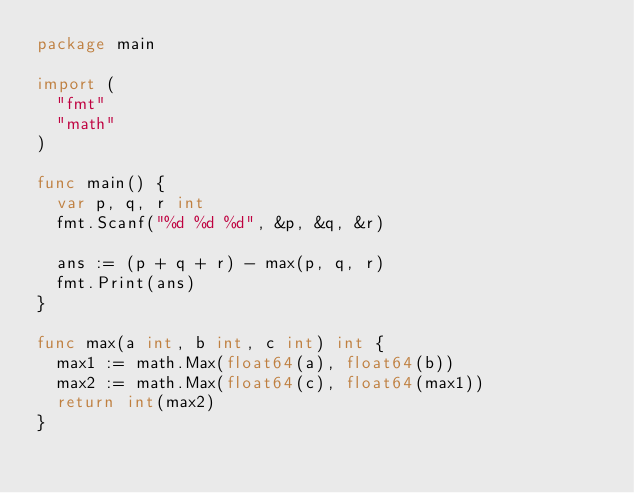<code> <loc_0><loc_0><loc_500><loc_500><_Go_>package main

import (
	"fmt"
	"math"
)

func main() {
	var p, q, r int
	fmt.Scanf("%d %d %d", &p, &q, &r)

	ans := (p + q + r) - max(p, q, r)
	fmt.Print(ans)
}

func max(a int, b int, c int) int {
	max1 := math.Max(float64(a), float64(b))
	max2 := math.Max(float64(c), float64(max1))
	return int(max2)
}
</code> 